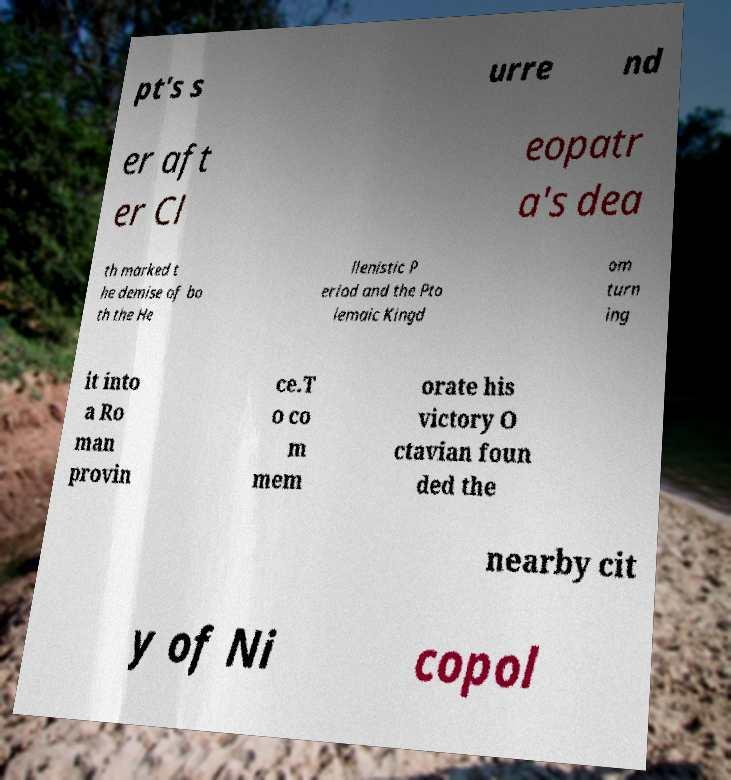Please read and relay the text visible in this image. What does it say? pt's s urre nd er aft er Cl eopatr a's dea th marked t he demise of bo th the He llenistic P eriod and the Pto lemaic Kingd om turn ing it into a Ro man provin ce.T o co m mem orate his victory O ctavian foun ded the nearby cit y of Ni copol 